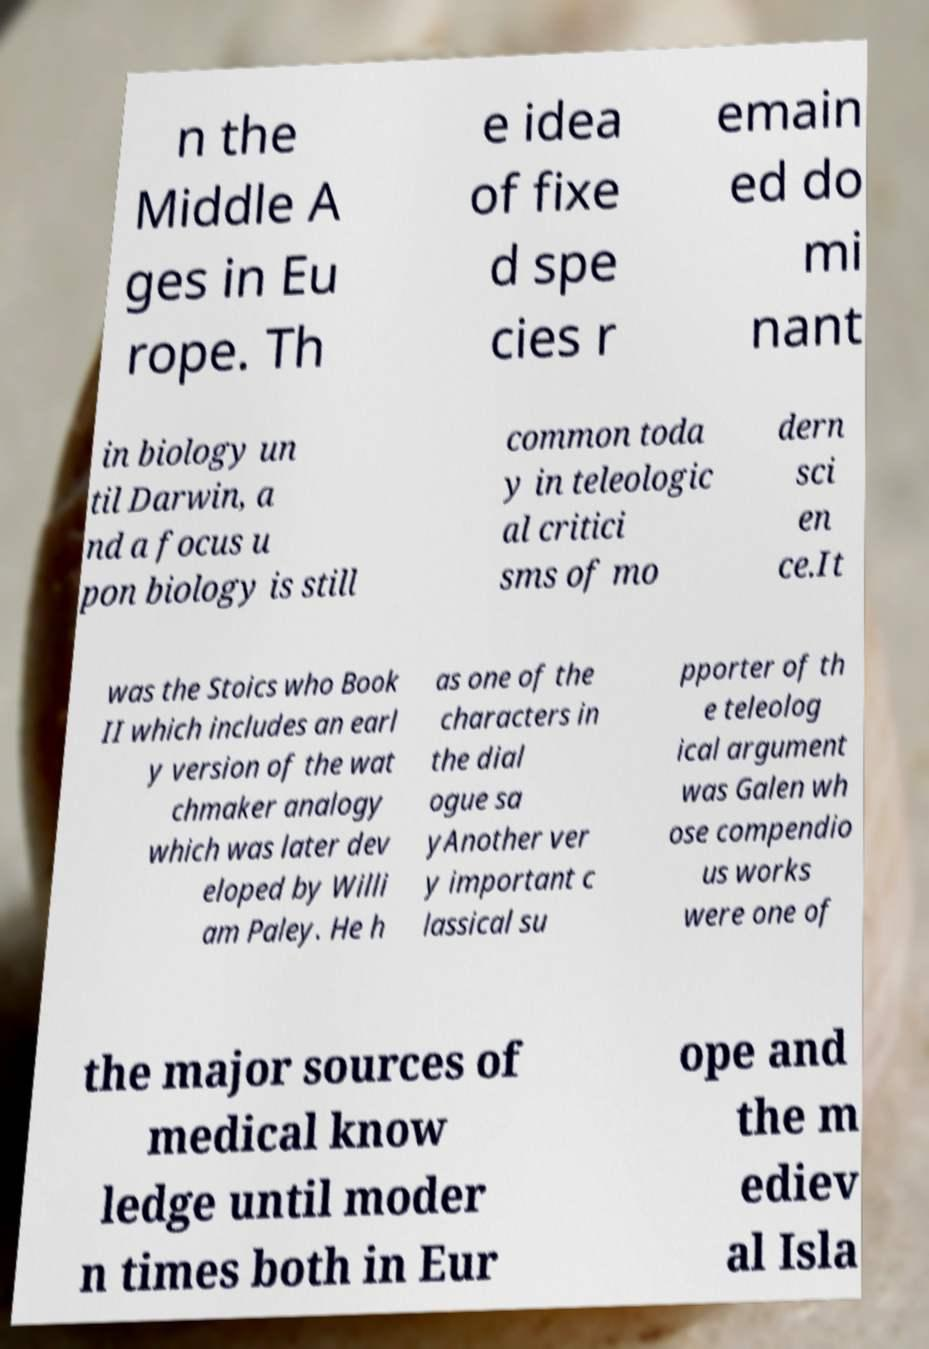Could you assist in decoding the text presented in this image and type it out clearly? n the Middle A ges in Eu rope. Th e idea of fixe d spe cies r emain ed do mi nant in biology un til Darwin, a nd a focus u pon biology is still common toda y in teleologic al critici sms of mo dern sci en ce.It was the Stoics who Book II which includes an earl y version of the wat chmaker analogy which was later dev eloped by Willi am Paley. He h as one of the characters in the dial ogue sa yAnother ver y important c lassical su pporter of th e teleolog ical argument was Galen wh ose compendio us works were one of the major sources of medical know ledge until moder n times both in Eur ope and the m ediev al Isla 